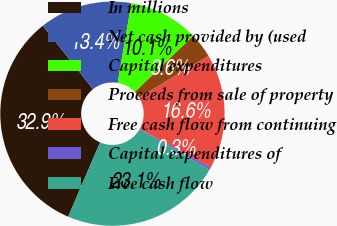Convert chart to OTSL. <chart><loc_0><loc_0><loc_500><loc_500><pie_chart><fcel>In millions<fcel>Net cash provided by (used<fcel>Capital expenditures<fcel>Proceeds from sale of property<fcel>Free cash flow from continuing<fcel>Capital expenditures of<fcel>Free cash flow<nl><fcel>32.89%<fcel>13.36%<fcel>10.1%<fcel>3.59%<fcel>16.61%<fcel>0.33%<fcel>23.12%<nl></chart> 